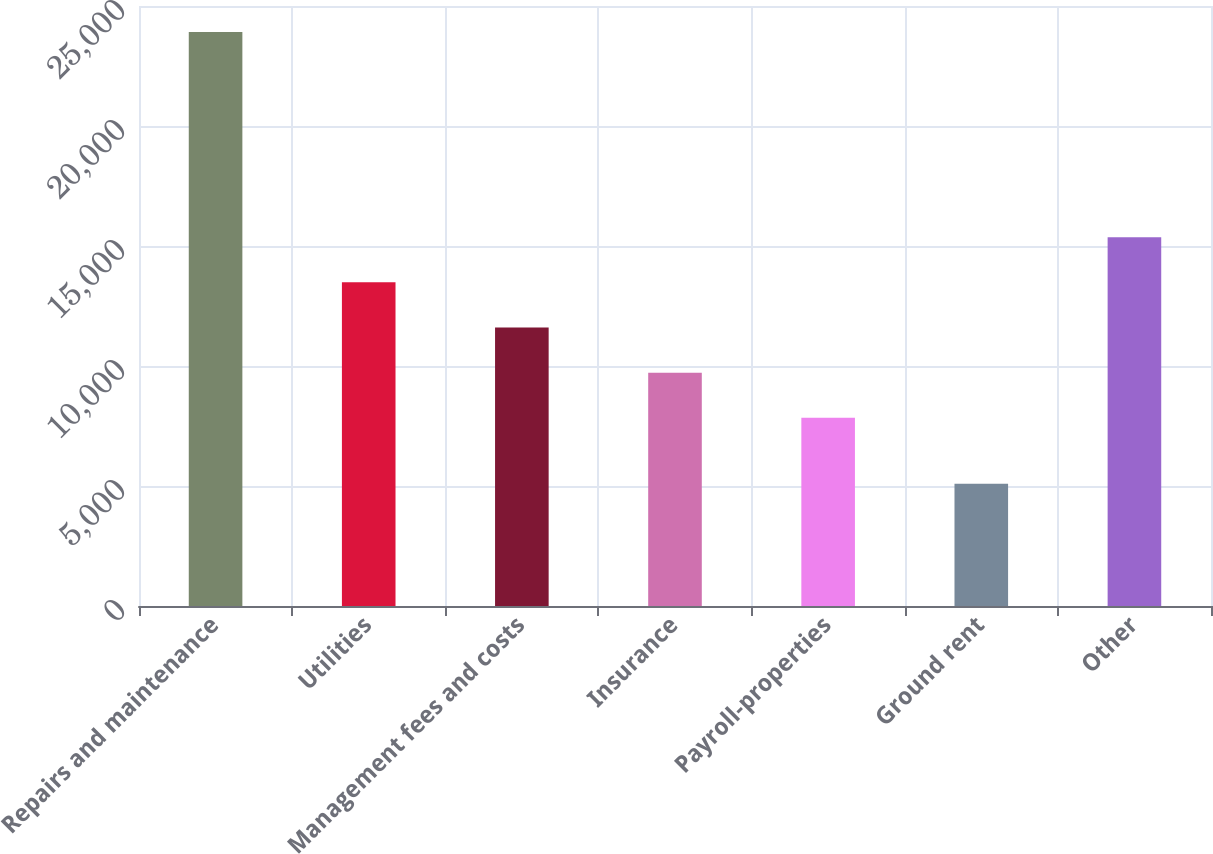<chart> <loc_0><loc_0><loc_500><loc_500><bar_chart><fcel>Repairs and maintenance<fcel>Utilities<fcel>Management fees and costs<fcel>Insurance<fcel>Payroll-properties<fcel>Ground rent<fcel>Other<nl><fcel>23913<fcel>13485.1<fcel>11603.4<fcel>9721.7<fcel>7840<fcel>5096<fcel>15366.8<nl></chart> 